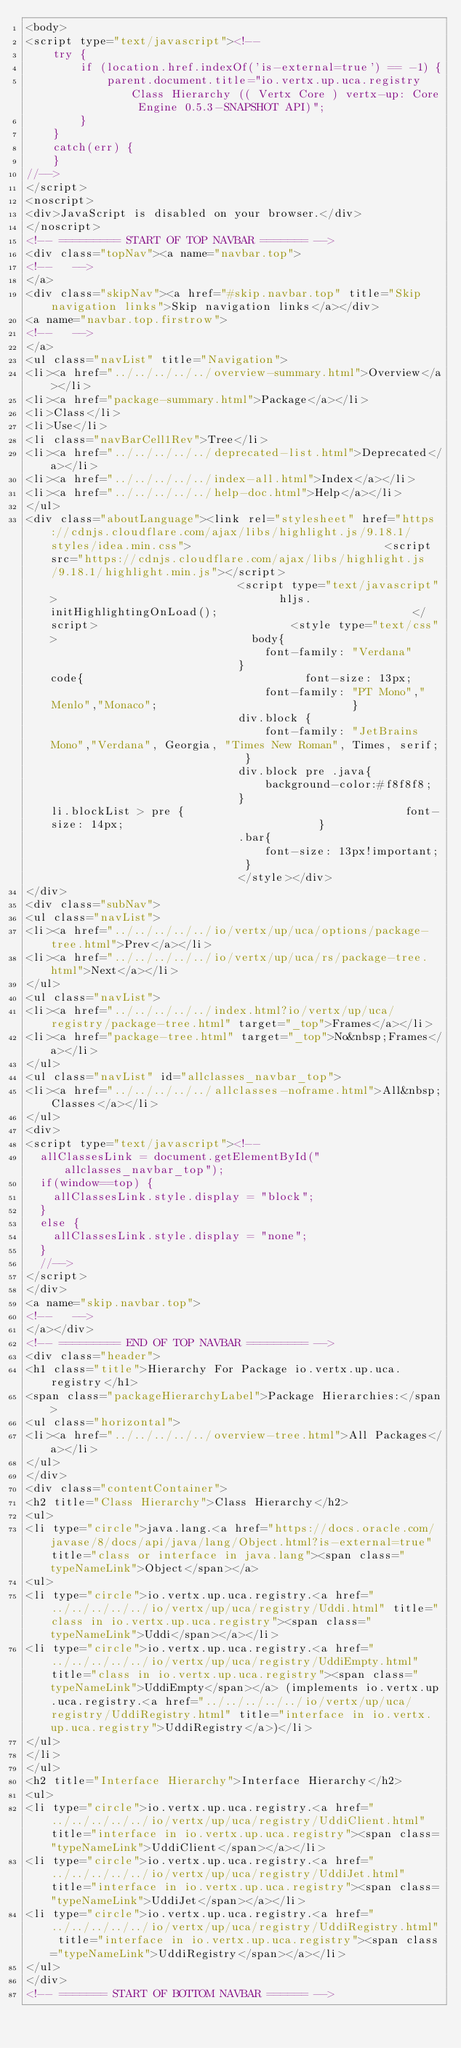Convert code to text. <code><loc_0><loc_0><loc_500><loc_500><_HTML_><body>
<script type="text/javascript"><!--
    try {
        if (location.href.indexOf('is-external=true') == -1) {
            parent.document.title="io.vertx.up.uca.registry Class Hierarchy (( Vertx Core ) vertx-up: Core Engine 0.5.3-SNAPSHOT API)";
        }
    }
    catch(err) {
    }
//-->
</script>
<noscript>
<div>JavaScript is disabled on your browser.</div>
</noscript>
<!-- ========= START OF TOP NAVBAR ======= -->
<div class="topNav"><a name="navbar.top">
<!--   -->
</a>
<div class="skipNav"><a href="#skip.navbar.top" title="Skip navigation links">Skip navigation links</a></div>
<a name="navbar.top.firstrow">
<!--   -->
</a>
<ul class="navList" title="Navigation">
<li><a href="../../../../../overview-summary.html">Overview</a></li>
<li><a href="package-summary.html">Package</a></li>
<li>Class</li>
<li>Use</li>
<li class="navBarCell1Rev">Tree</li>
<li><a href="../../../../../deprecated-list.html">Deprecated</a></li>
<li><a href="../../../../../index-all.html">Index</a></li>
<li><a href="../../../../../help-doc.html">Help</a></li>
</ul>
<div class="aboutLanguage"><link rel="stylesheet" href="https://cdnjs.cloudflare.com/ajax/libs/highlight.js/9.18.1/styles/idea.min.css">                             <script src="https://cdnjs.cloudflare.com/ajax/libs/highlight.js/9.18.1/highlight.min.js"></script>                             <script type="text/javascript">                                 hljs.initHighlightingOnLoad();                             </script>                             <style type="text/css">                             body{                                 font-family: "Verdana"                             }                             code{                                 font-size: 13px;                                 font-family: "PT Mono","Menlo","Monaco";                             }                             div.block {                                 font-family: "JetBrains Mono","Verdana", Georgia, "Times New Roman", Times, serif;                             }                             div.block pre .java{                                 background-color:#f8f8f8;                             }                             li.blockList > pre {                                 font-size: 14px;                             }                             .bar{                                 font-size: 13px!important;                             }                             </style></div>
</div>
<div class="subNav">
<ul class="navList">
<li><a href="../../../../../io/vertx/up/uca/options/package-tree.html">Prev</a></li>
<li><a href="../../../../../io/vertx/up/uca/rs/package-tree.html">Next</a></li>
</ul>
<ul class="navList">
<li><a href="../../../../../index.html?io/vertx/up/uca/registry/package-tree.html" target="_top">Frames</a></li>
<li><a href="package-tree.html" target="_top">No&nbsp;Frames</a></li>
</ul>
<ul class="navList" id="allclasses_navbar_top">
<li><a href="../../../../../allclasses-noframe.html">All&nbsp;Classes</a></li>
</ul>
<div>
<script type="text/javascript"><!--
  allClassesLink = document.getElementById("allclasses_navbar_top");
  if(window==top) {
    allClassesLink.style.display = "block";
  }
  else {
    allClassesLink.style.display = "none";
  }
  //-->
</script>
</div>
<a name="skip.navbar.top">
<!--   -->
</a></div>
<!-- ========= END OF TOP NAVBAR ========= -->
<div class="header">
<h1 class="title">Hierarchy For Package io.vertx.up.uca.registry</h1>
<span class="packageHierarchyLabel">Package Hierarchies:</span>
<ul class="horizontal">
<li><a href="../../../../../overview-tree.html">All Packages</a></li>
</ul>
</div>
<div class="contentContainer">
<h2 title="Class Hierarchy">Class Hierarchy</h2>
<ul>
<li type="circle">java.lang.<a href="https://docs.oracle.com/javase/8/docs/api/java/lang/Object.html?is-external=true" title="class or interface in java.lang"><span class="typeNameLink">Object</span></a>
<ul>
<li type="circle">io.vertx.up.uca.registry.<a href="../../../../../io/vertx/up/uca/registry/Uddi.html" title="class in io.vertx.up.uca.registry"><span class="typeNameLink">Uddi</span></a></li>
<li type="circle">io.vertx.up.uca.registry.<a href="../../../../../io/vertx/up/uca/registry/UddiEmpty.html" title="class in io.vertx.up.uca.registry"><span class="typeNameLink">UddiEmpty</span></a> (implements io.vertx.up.uca.registry.<a href="../../../../../io/vertx/up/uca/registry/UddiRegistry.html" title="interface in io.vertx.up.uca.registry">UddiRegistry</a>)</li>
</ul>
</li>
</ul>
<h2 title="Interface Hierarchy">Interface Hierarchy</h2>
<ul>
<li type="circle">io.vertx.up.uca.registry.<a href="../../../../../io/vertx/up/uca/registry/UddiClient.html" title="interface in io.vertx.up.uca.registry"><span class="typeNameLink">UddiClient</span></a></li>
<li type="circle">io.vertx.up.uca.registry.<a href="../../../../../io/vertx/up/uca/registry/UddiJet.html" title="interface in io.vertx.up.uca.registry"><span class="typeNameLink">UddiJet</span></a></li>
<li type="circle">io.vertx.up.uca.registry.<a href="../../../../../io/vertx/up/uca/registry/UddiRegistry.html" title="interface in io.vertx.up.uca.registry"><span class="typeNameLink">UddiRegistry</span></a></li>
</ul>
</div>
<!-- ======= START OF BOTTOM NAVBAR ====== --></code> 